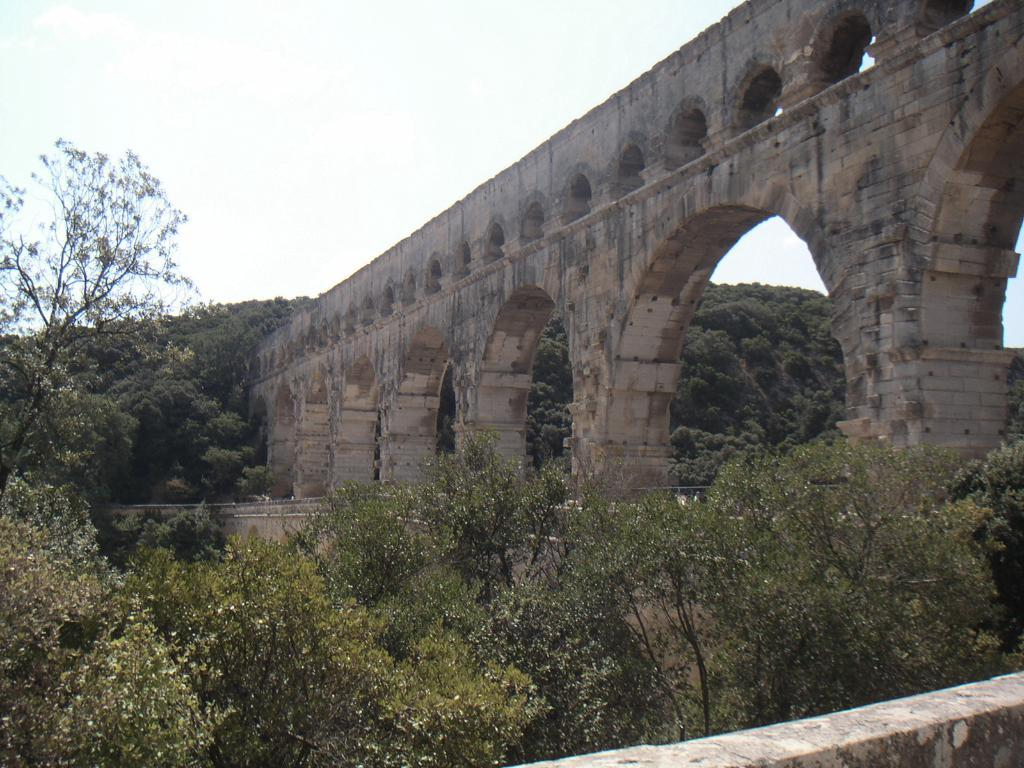What type of structure is present in the image? There is a bridge in the image. Can you describe the bridge's design? The bridge has many arches. What can be seen at the bottom of the image? There are trees at the bottom of the image. What is visible in the sky at the top of the image? There are clouds in the sky at the top of the image. What type of music can be heard playing in the background of the image? There is no music present in the image, as it is a visual representation of a bridge with trees and clouds. 